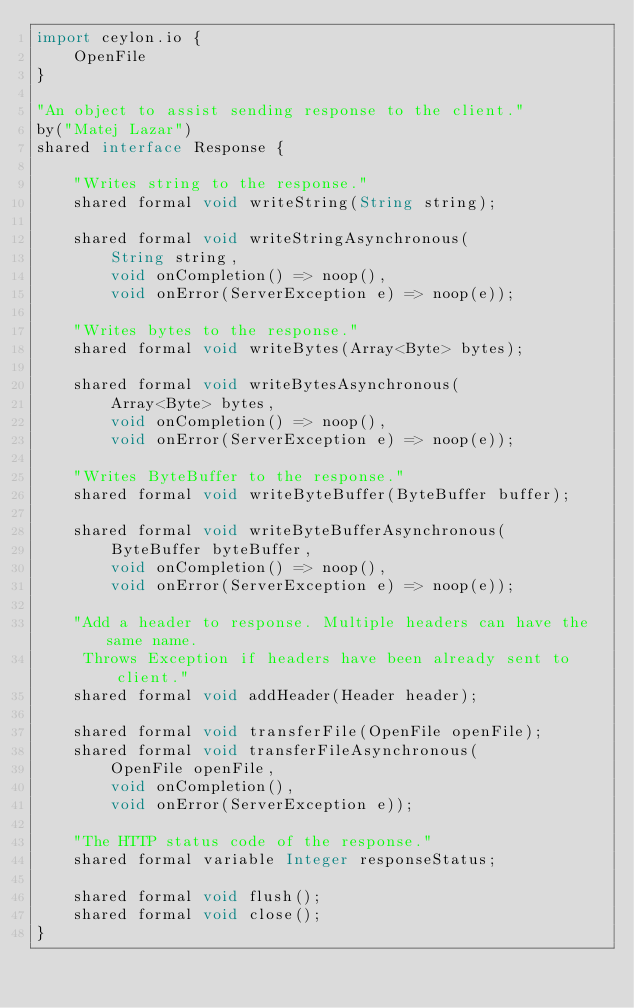<code> <loc_0><loc_0><loc_500><loc_500><_Ceylon_>import ceylon.io {
    OpenFile
}

"An object to assist sending response to the client."
by("Matej Lazar")
shared interface Response {

    "Writes string to the response."
    shared formal void writeString(String string);

    shared formal void writeStringAsynchronous(
        String string, 
        void onCompletion() => noop(),
        void onError(ServerException e) => noop(e));

    "Writes bytes to the response."
    shared formal void writeBytes(Array<Byte> bytes);

    shared formal void writeBytesAsynchronous(
        Array<Byte> bytes,
        void onCompletion() => noop(),
        void onError(ServerException e) => noop(e));

    "Writes ByteBuffer to the response."
    shared formal void writeByteBuffer(ByteBuffer buffer);

    shared formal void writeByteBufferAsynchronous(
        ByteBuffer byteBuffer,
        void onCompletion() => noop(),
        void onError(ServerException e) => noop(e));

    "Add a header to response. Multiple headers can have the same name.
     Throws Exception if headers have been already sent to client."
    shared formal void addHeader(Header header);

    shared formal void transferFile(OpenFile openFile);
    shared formal void transferFileAsynchronous(
        OpenFile openFile,
        void onCompletion(),
        void onError(ServerException e));

    "The HTTP status code of the response."
    shared formal variable Integer responseStatus;

    shared formal void flush();
    shared formal void close();
}
</code> 